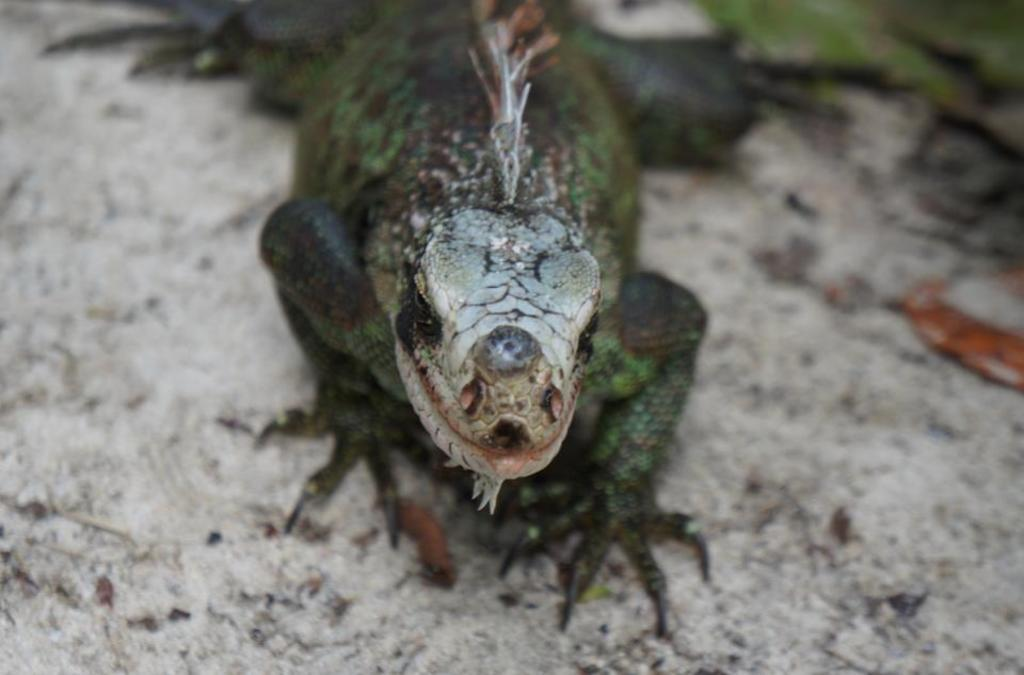What type of animal is in the image? There is a reptile in the image. Can you describe the background of the image? The background of the reptile is blurred. What reward is the reptile receiving for stopping at the dock in the image? There is no dock or reward present in the image; it only features a reptile with a blurred background. 